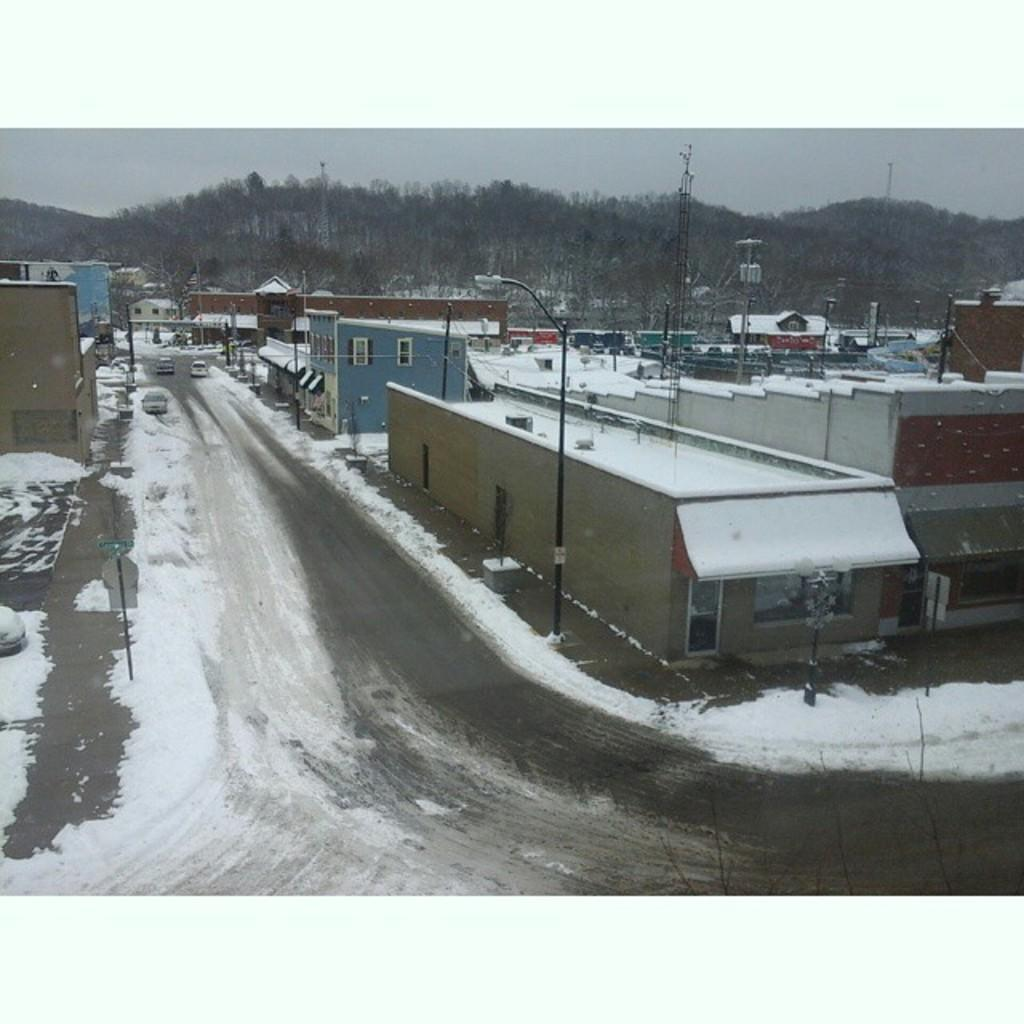What can be seen in the sky in the image? The sky is visible in the image, and clouds are present. What type of vegetation is in the image? Trees are in the image. What structures are in the image? Poles, buildings, and sign boards are in the image. What architectural features are in the image? Windows are in the image. What is the weather like in the image? Snow is visible in the image, indicating a winter scene. What type of transportation is in the image? There are vehicles on the road in the image. Are there any other objects in the image? Yes, there are other objects in the image. What type of branch is hanging from the flag in the image? There is no flag present in the image, so there is no branch hanging from it. 